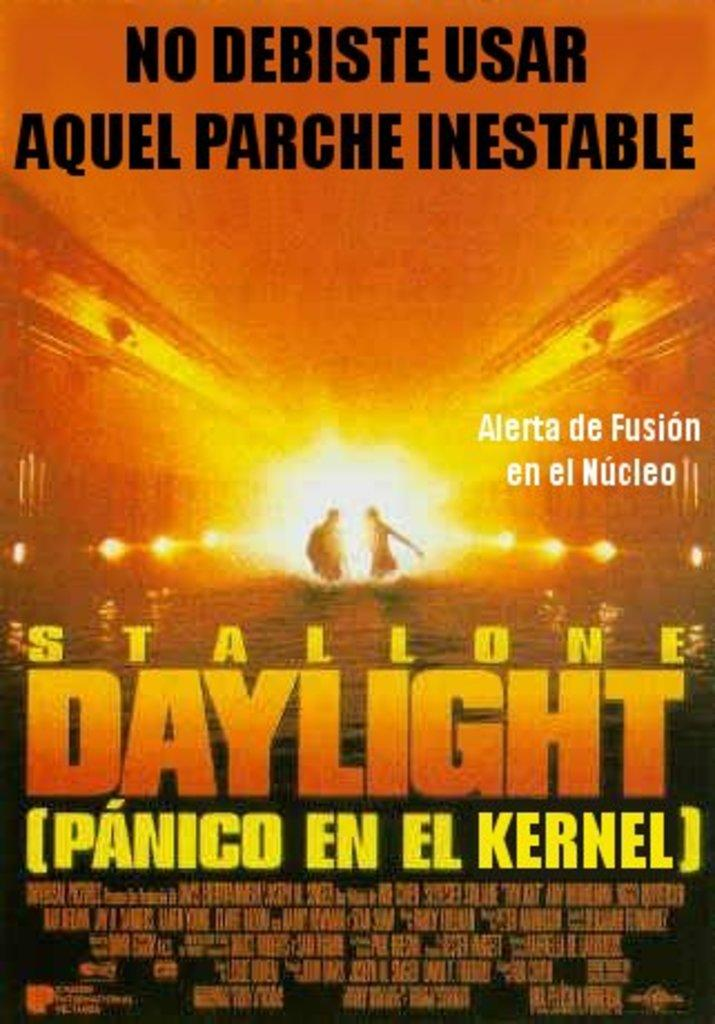<image>
Describe the image concisely. The Spanish language movie poster for "Daylight" starring Stallone. 